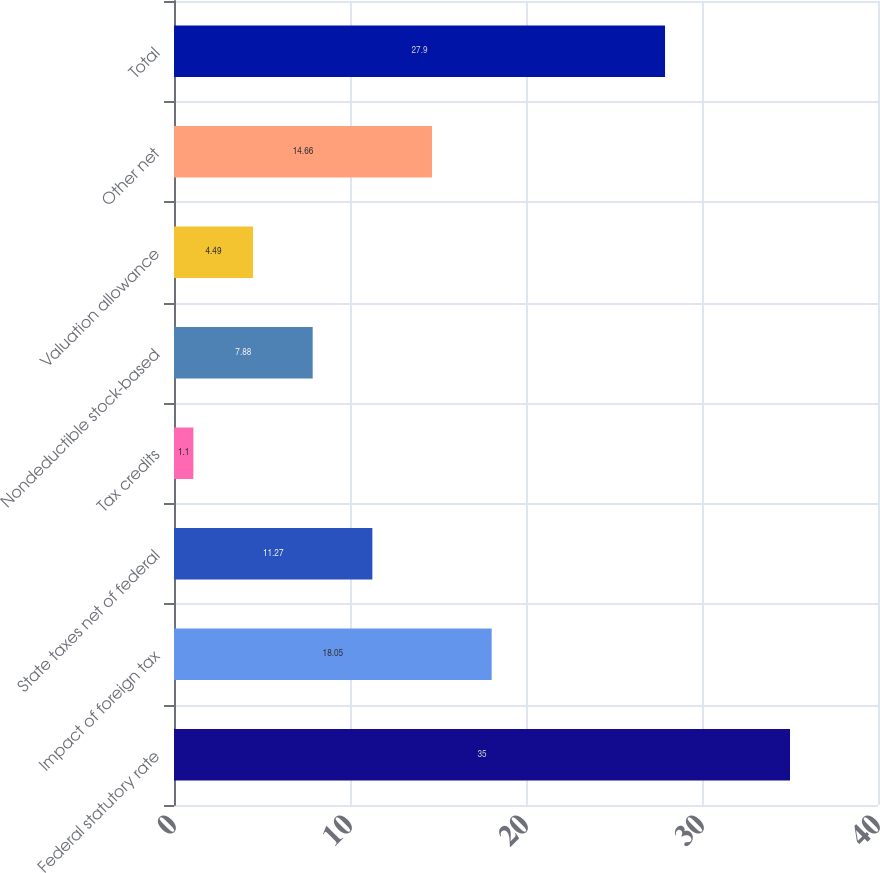Convert chart to OTSL. <chart><loc_0><loc_0><loc_500><loc_500><bar_chart><fcel>Federal statutory rate<fcel>Impact of foreign tax<fcel>State taxes net of federal<fcel>Tax credits<fcel>Nondeductible stock-based<fcel>Valuation allowance<fcel>Other net<fcel>Total<nl><fcel>35<fcel>18.05<fcel>11.27<fcel>1.1<fcel>7.88<fcel>4.49<fcel>14.66<fcel>27.9<nl></chart> 